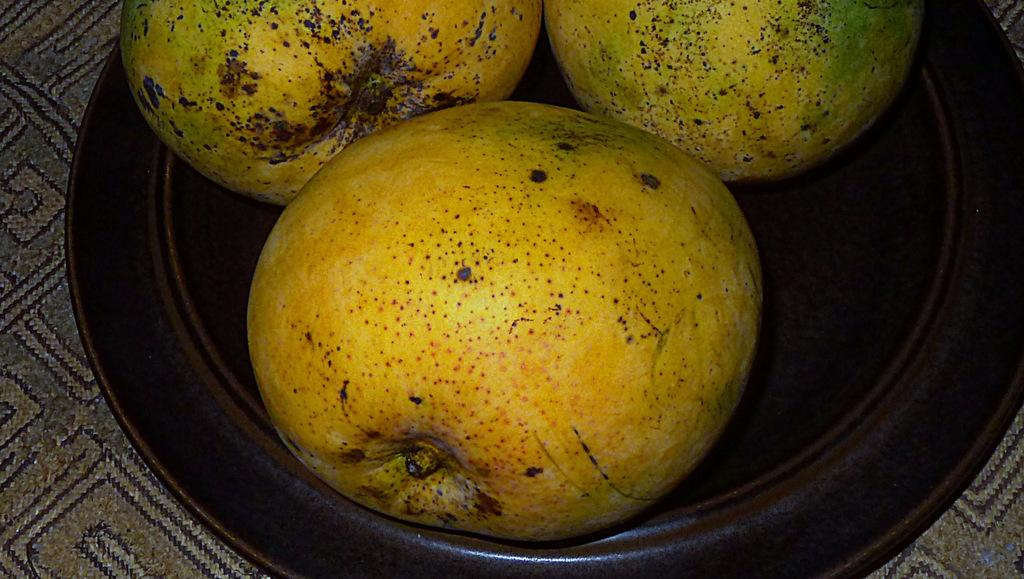What is on the plate that is visible in the image? There are fruits on a plate in the image. What is the color of the plate? The plate is brown in color. What can be seen at the bottom of the image? There is a cloth at the bottom of the image. What does the aunt hope for in the image? There is no aunt present in the image, so it is not possible to determine what she might hope for. 